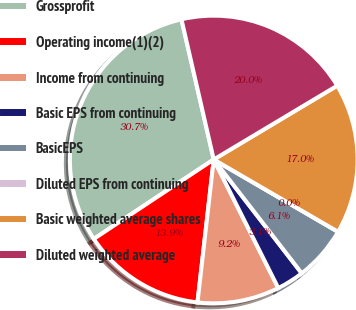Convert chart to OTSL. <chart><loc_0><loc_0><loc_500><loc_500><pie_chart><fcel>Grossprofit<fcel>Operating income(1)(2)<fcel>Income from continuing<fcel>Basic EPS from continuing<fcel>BasicEPS<fcel>Diluted EPS from continuing<fcel>Basic weighted average shares<fcel>Diluted weighted average<nl><fcel>30.71%<fcel>13.89%<fcel>9.21%<fcel>3.07%<fcel>6.14%<fcel>0.0%<fcel>16.96%<fcel>20.03%<nl></chart> 